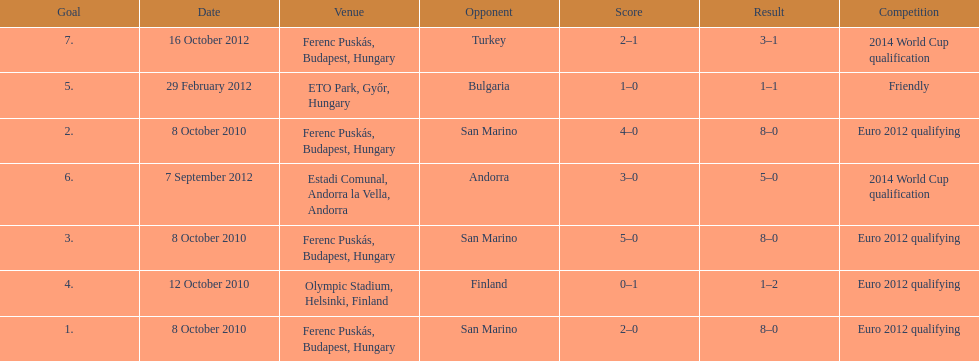How many goals were scored at the euro 2012 qualifying competition? 12. 